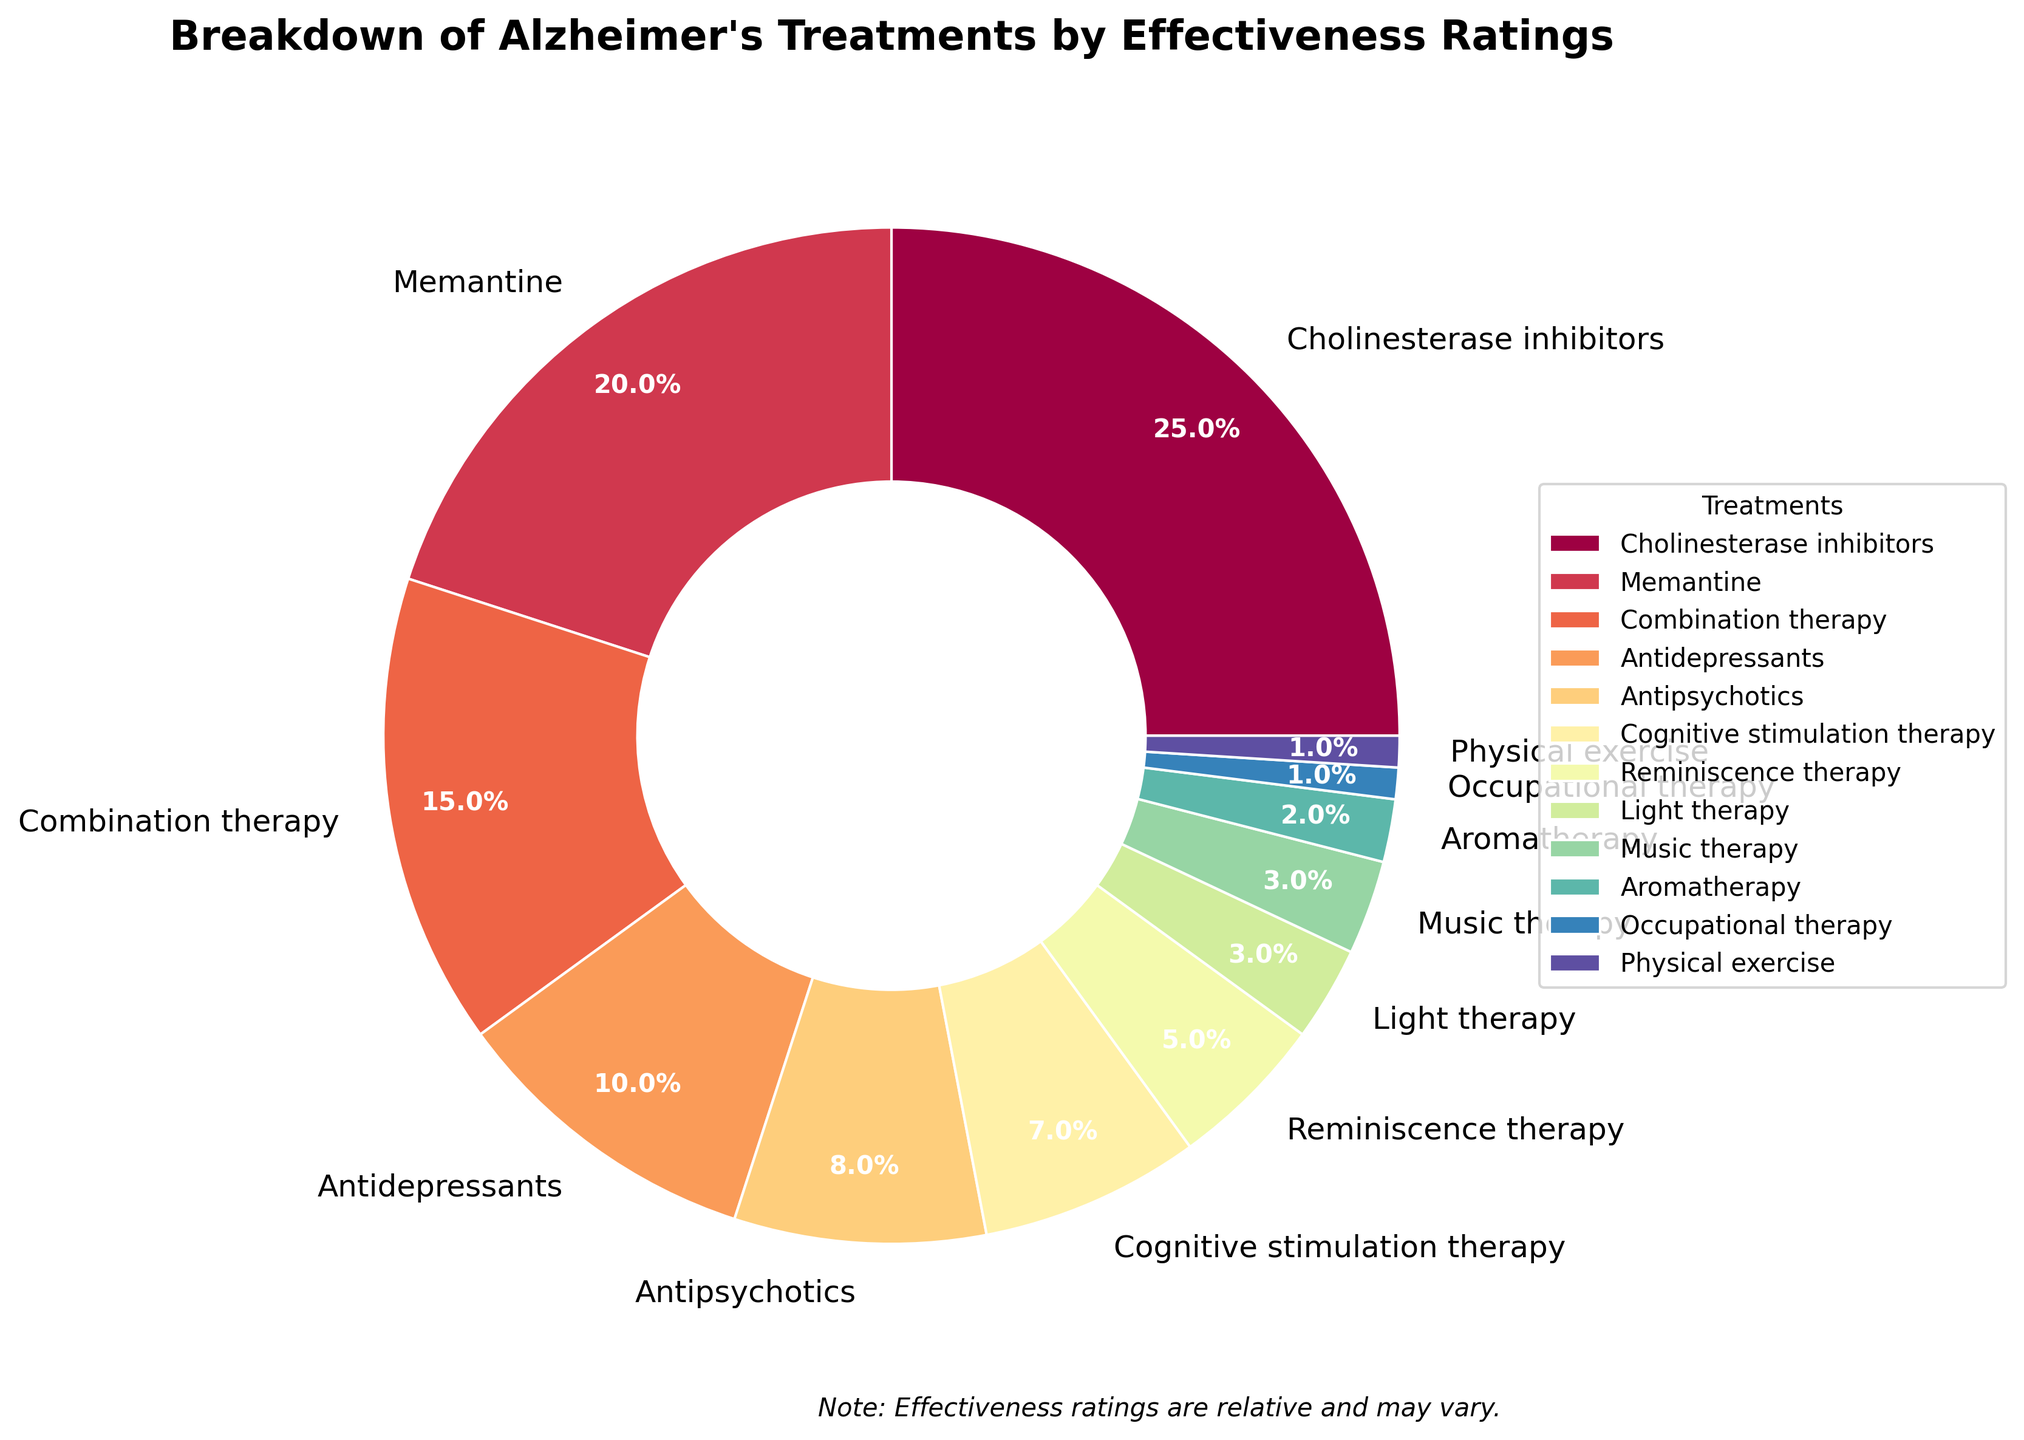Which treatment has the highest effectiveness rating? The treatment with the highest effectiveness rating is the one with the largest proportion of the pie. This is Cholinesterase inhibitors.
Answer: Cholinesterase inhibitors What is the combined effectiveness rating percentage for Memantine and Combination therapy? To get the combined effectiveness rating percentage, sum the percentages of Memantine (20%) and Combination therapy (15%). So, 20% + 15% = 35%.
Answer: 35% Are Antidepressants more effective than Cognitive stimulation therapy? Compare the effectiveness ratings of both treatments. Antidepressants have a rating of 10%, whereas Cognitive stimulation therapy has a rating of 7%. So, Antidepressants are more effective.
Answer: Yes Which three treatments have the lowest effectiveness ratings? Identify the smallest segments of the pie chart. The treatments with the lowest ratings are Occupational therapy (1%), Physical exercise (1%), and Aromatherapy (2%).
Answer: Occupational therapy, Physical exercise, Aromatherapy What is the difference in effectiveness ratings between Cholinesterase inhibitors and Antipsychotics? Subtract the effectiveness rating of Antipsychotics (8%) from the rating of Cholinesterase inhibitors (25%). So, 25% - 8% = 17%.
Answer: 17% How does the effectiveness rating of Music therapy compare to Light therapy? Both Music therapy and Light therapy have the same effectiveness rating as they cover equal proportions of the pie chart, both rated at 3%.
Answer: Equal Is Combination therapy more effective than both Light therapy and Music therapy combined? Sum the ratings of Light therapy (3%) and Music therapy (3%) for a combined rating of 6%. Combination therapy has a rating of 15%, which is greater than the combined 6%.
Answer: Yes Which section of the pie chart shows the largest single effectiveness rating besides Cholinesterase inhibitors? Identify the second-largest section after Cholinesterase inhibitors, which is Memantine with a rating of 20%.
Answer: Memantine What is the total percentage of treatments with an effectiveness rating of 10% or less? Sum the effectiveness ratings of Antidepressants (10%), Antipsychotics (8%), Cognitive stimulation therapy (7%), Reminiscence therapy (5%), Light therapy (3%), Music therapy (3%), Aromatherapy (2%), Occupational therapy (1%), and Physical exercise (1%). This totals to 40%.
Answer: 40% Which treatment is less effective: Reminiscence therapy or Occupational therapy? Compare the effectiveness ratings of Reminiscence therapy (5%) and Occupational therapy (1%). Occupational therapy is less effective.
Answer: Occupational therapy 